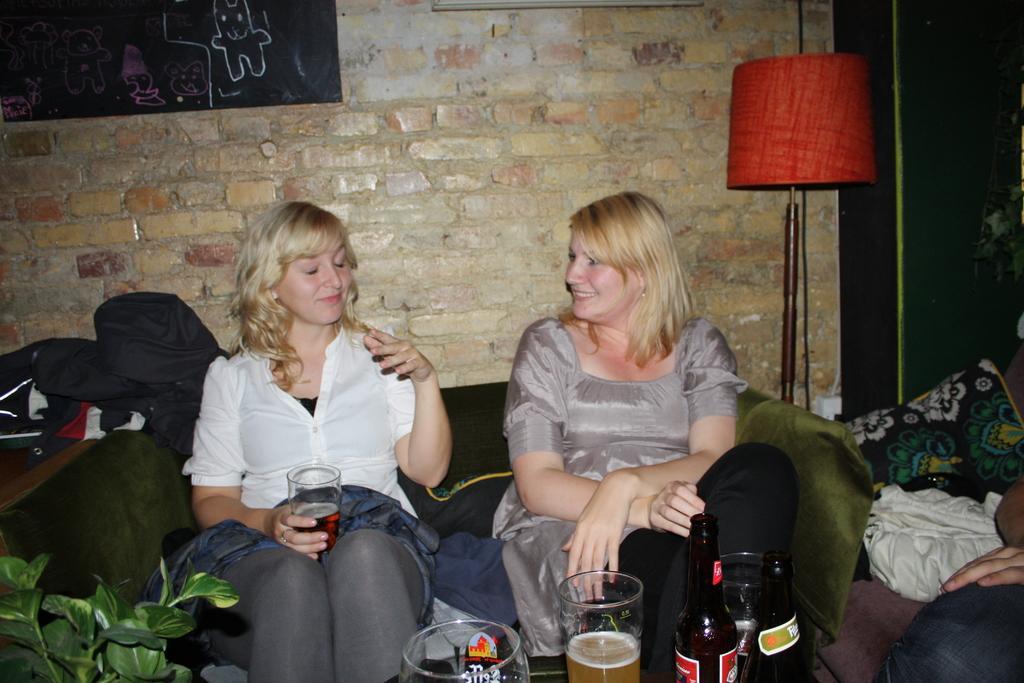Describe this image in one or two sentences. As we can see in the image there is a brick wall, black color board, lamp and two people sitting on sofas. In the front there are glasses and bottle. 